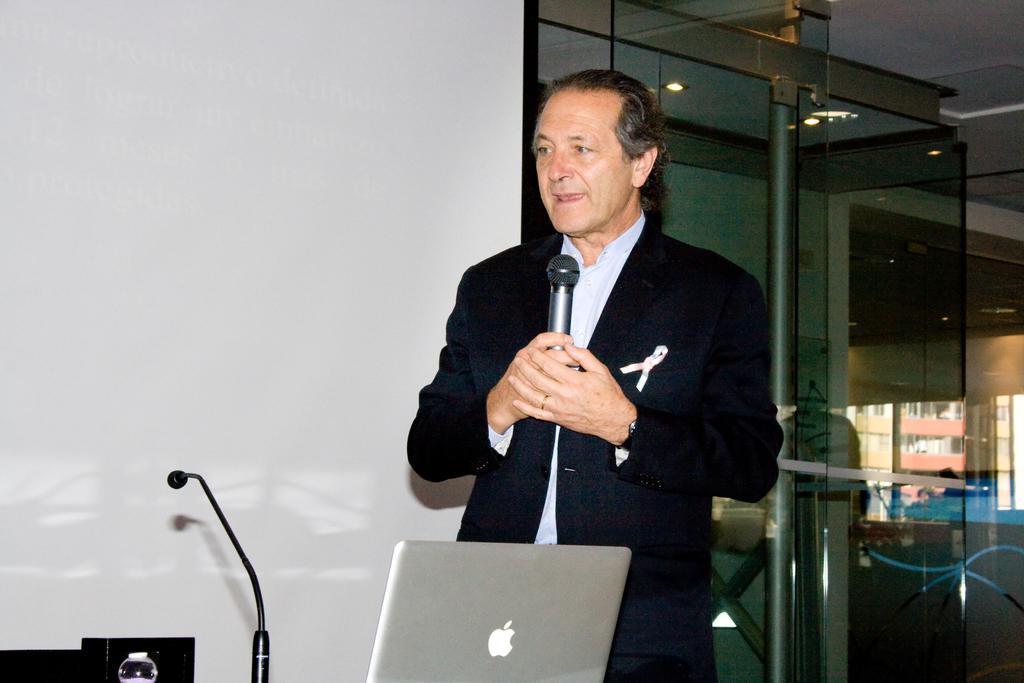Describe this image in one or two sentences. This picture shows a man standing and holding a microphone and speaking and we see a laptop and another microphone on the side 